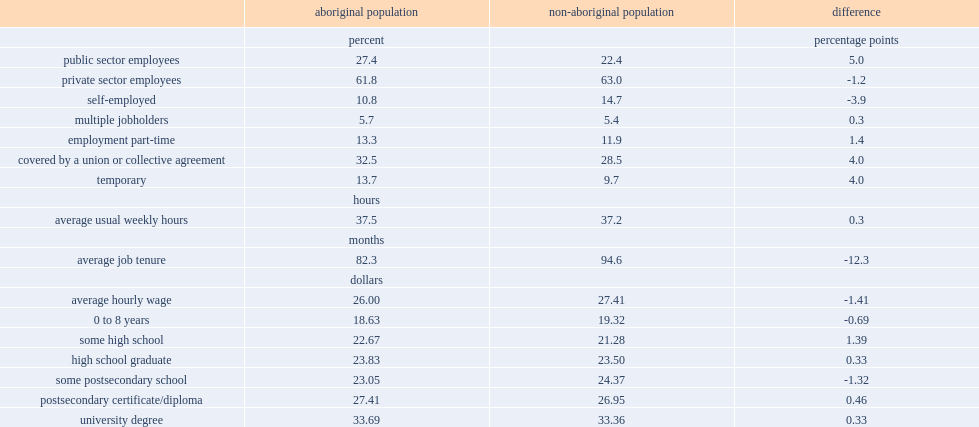Self-employment was less common among which type of people, aboriginal people or non-aboriginal people? Aboriginal population. Which group of people were slightly less likely to work in the private sector, aboriginal people or non-aboriginal people? Aboriginal population. Which group of people were more likely to work in the public sector, aboriginal people or non-aboriginal people? Aboriginal population. What was an average dollars per hour did aboriginal employees working full-time earne? 26.0. What was an average dollars per hour did non-aboriginal employees working full-time earne? 27.41. 